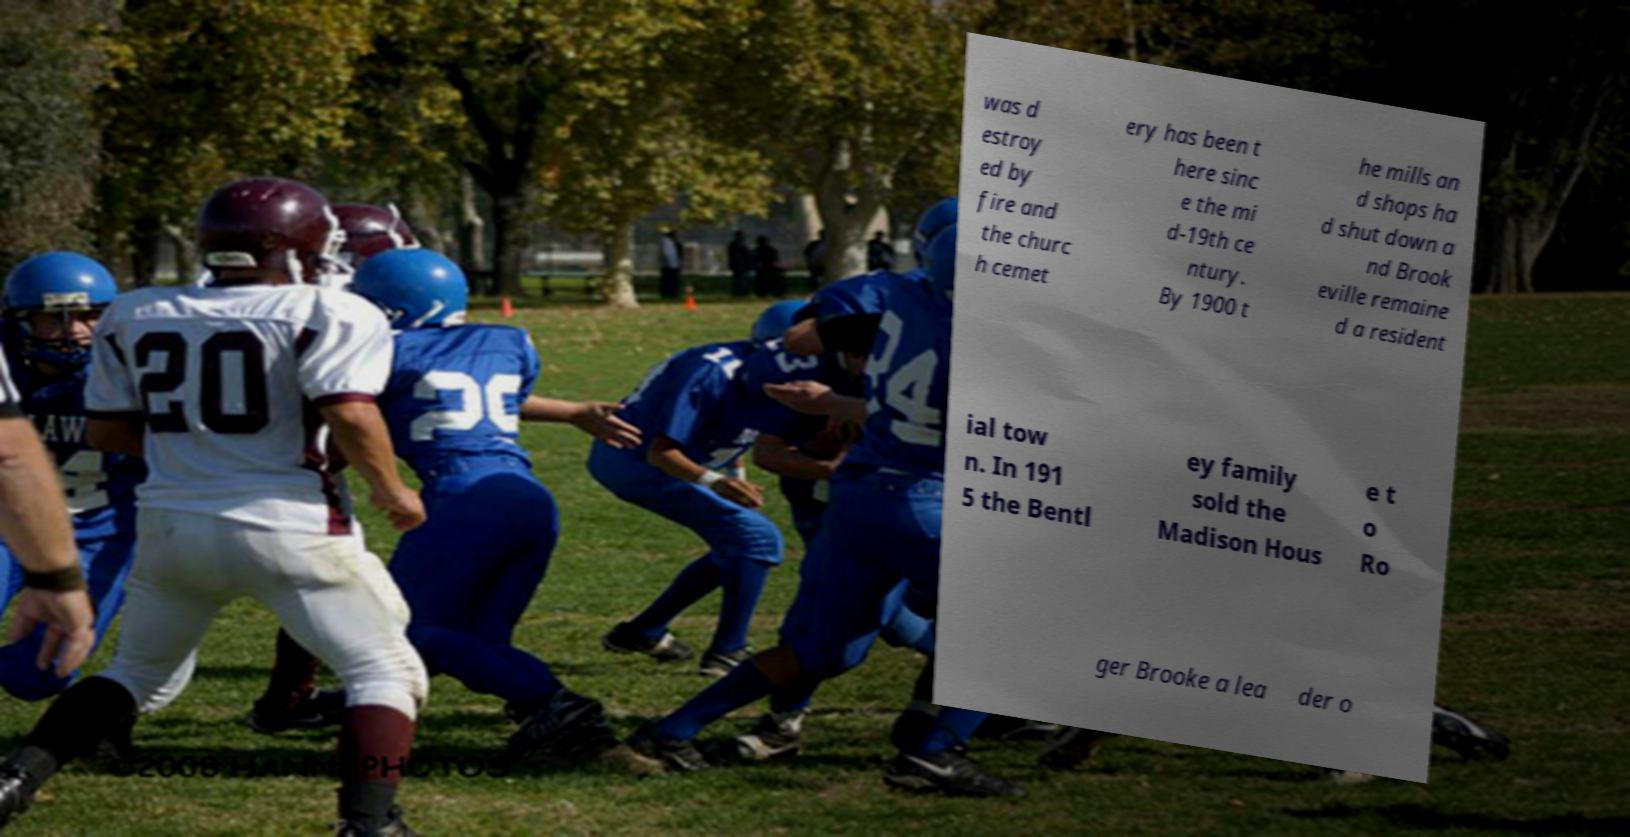For documentation purposes, I need the text within this image transcribed. Could you provide that? was d estroy ed by fire and the churc h cemet ery has been t here sinc e the mi d-19th ce ntury. By 1900 t he mills an d shops ha d shut down a nd Brook eville remaine d a resident ial tow n. In 191 5 the Bentl ey family sold the Madison Hous e t o Ro ger Brooke a lea der o 